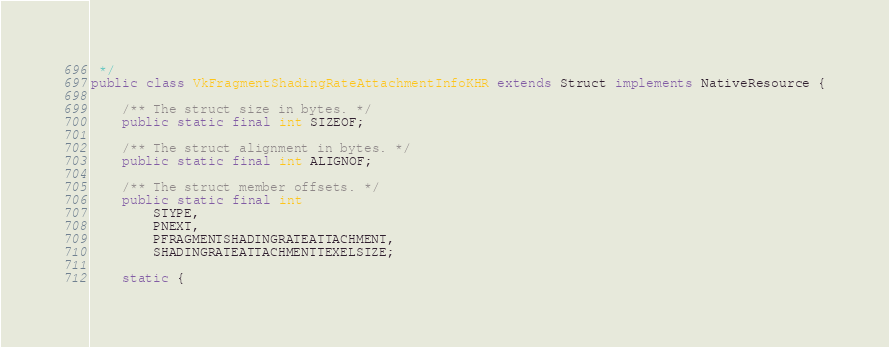Convert code to text. <code><loc_0><loc_0><loc_500><loc_500><_Java_> */
public class VkFragmentShadingRateAttachmentInfoKHR extends Struct implements NativeResource {

    /** The struct size in bytes. */
    public static final int SIZEOF;

    /** The struct alignment in bytes. */
    public static final int ALIGNOF;

    /** The struct member offsets. */
    public static final int
        STYPE,
        PNEXT,
        PFRAGMENTSHADINGRATEATTACHMENT,
        SHADINGRATEATTACHMENTTEXELSIZE;

    static {</code> 